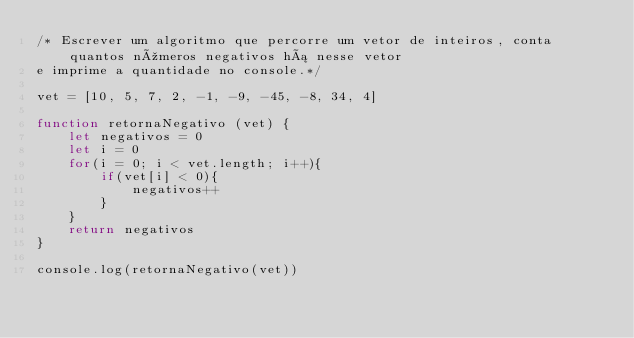Convert code to text. <code><loc_0><loc_0><loc_500><loc_500><_JavaScript_>/* Escrever um algoritmo que percorre um vetor de inteiros, conta quantos números negativos há nesse vetor
e imprime a quantidade no console.*/

vet = [10, 5, 7, 2, -1, -9, -45, -8, 34, 4]

function retornaNegativo (vet) {
    let negativos = 0
    let i = 0
    for(i = 0; i < vet.length; i++){
        if(vet[i] < 0){
            negativos++
        }
    }
    return negativos
}

console.log(retornaNegativo(vet))</code> 